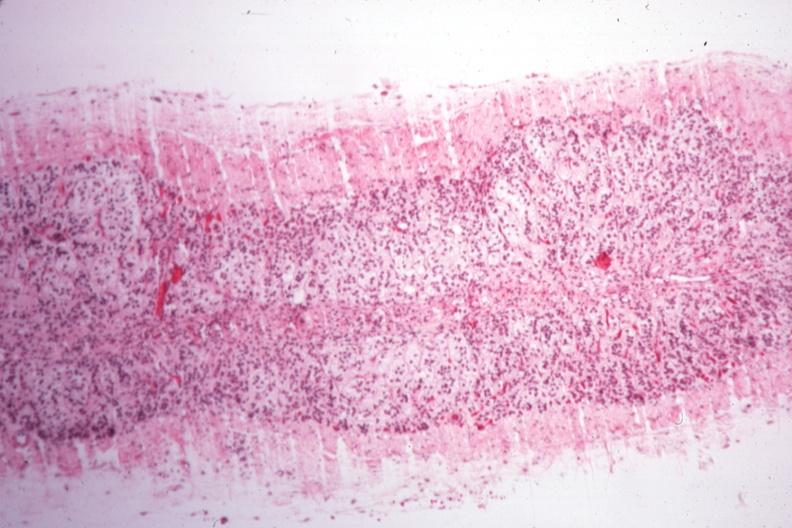what is present?
Answer the question using a single word or phrase. Endocrine 